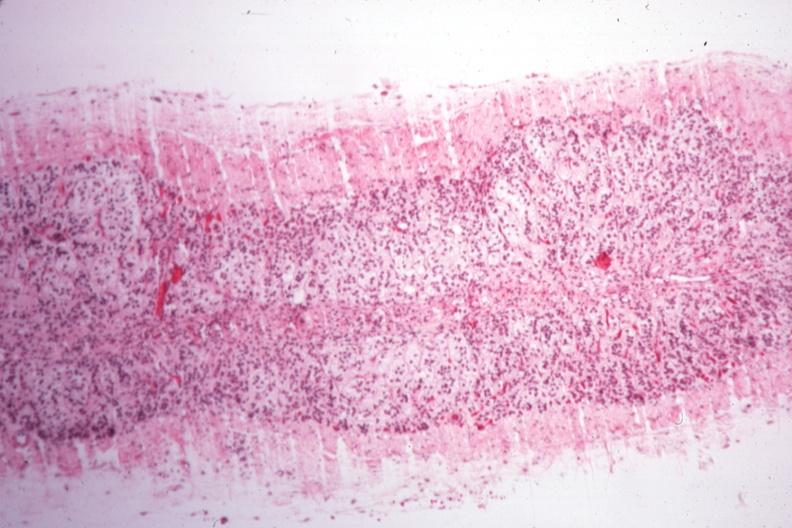what is present?
Answer the question using a single word or phrase. Endocrine 